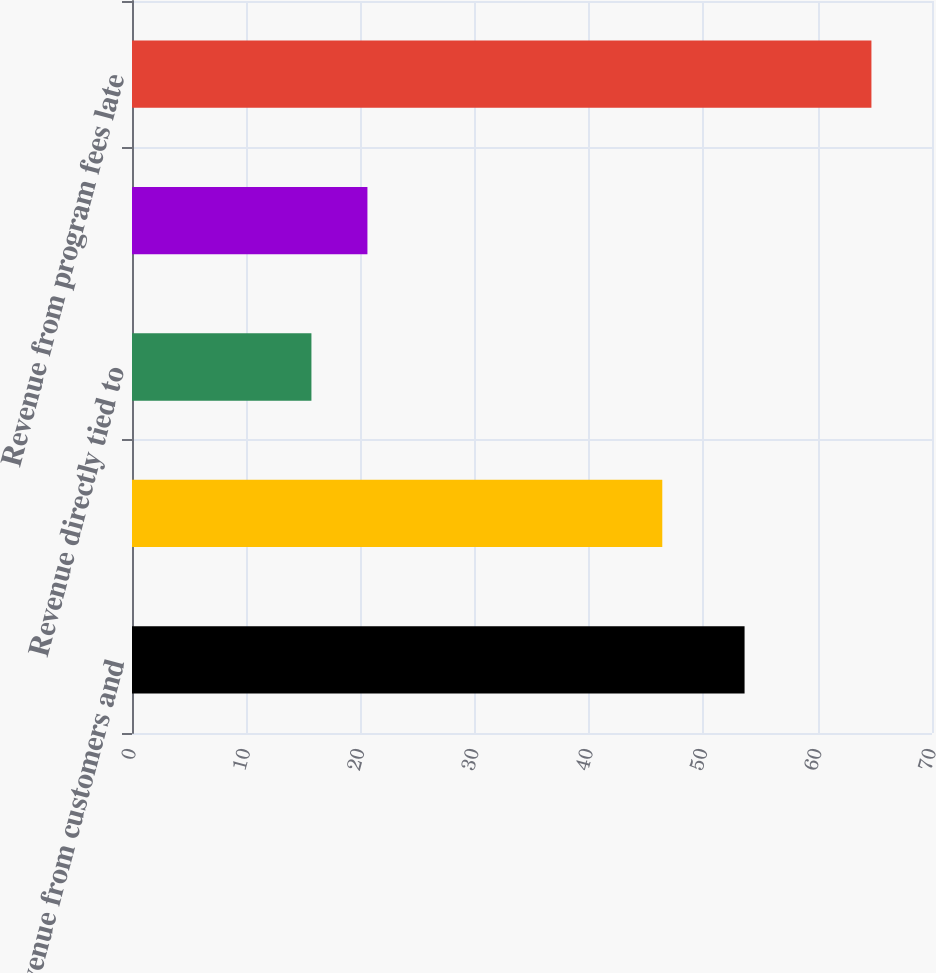Convert chart to OTSL. <chart><loc_0><loc_0><loc_500><loc_500><bar_chart><fcel>Revenue from customers and<fcel>Revenue from merchants and<fcel>Revenue directly tied to<fcel>Revenue directly influenced by<fcel>Revenue from program fees late<nl><fcel>53.6<fcel>46.4<fcel>15.7<fcel>20.6<fcel>64.7<nl></chart> 